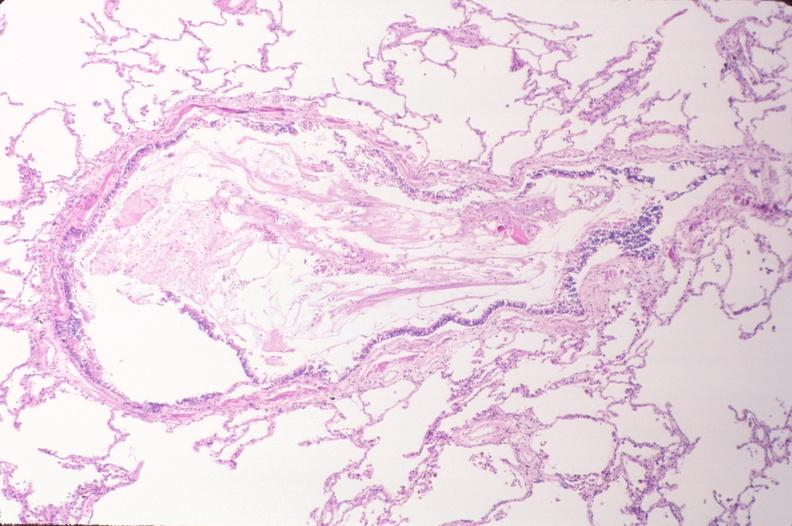where is this?
Answer the question using a single word or phrase. Lung 